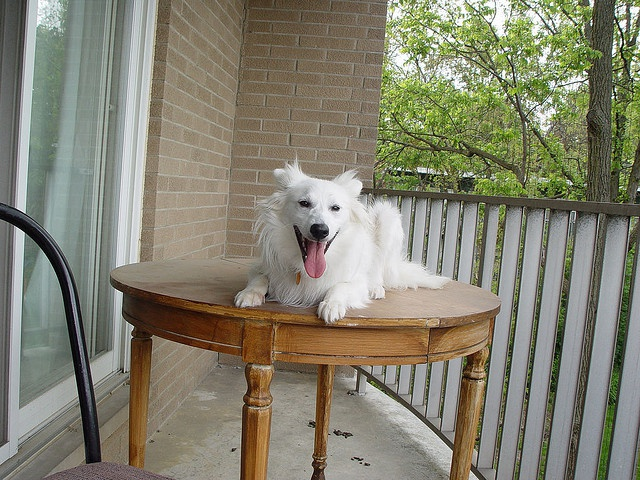Describe the objects in this image and their specific colors. I can see dining table in black, maroon, olive, and gray tones, dog in black, lightgray, darkgray, and gray tones, and chair in black, gray, and darkgray tones in this image. 